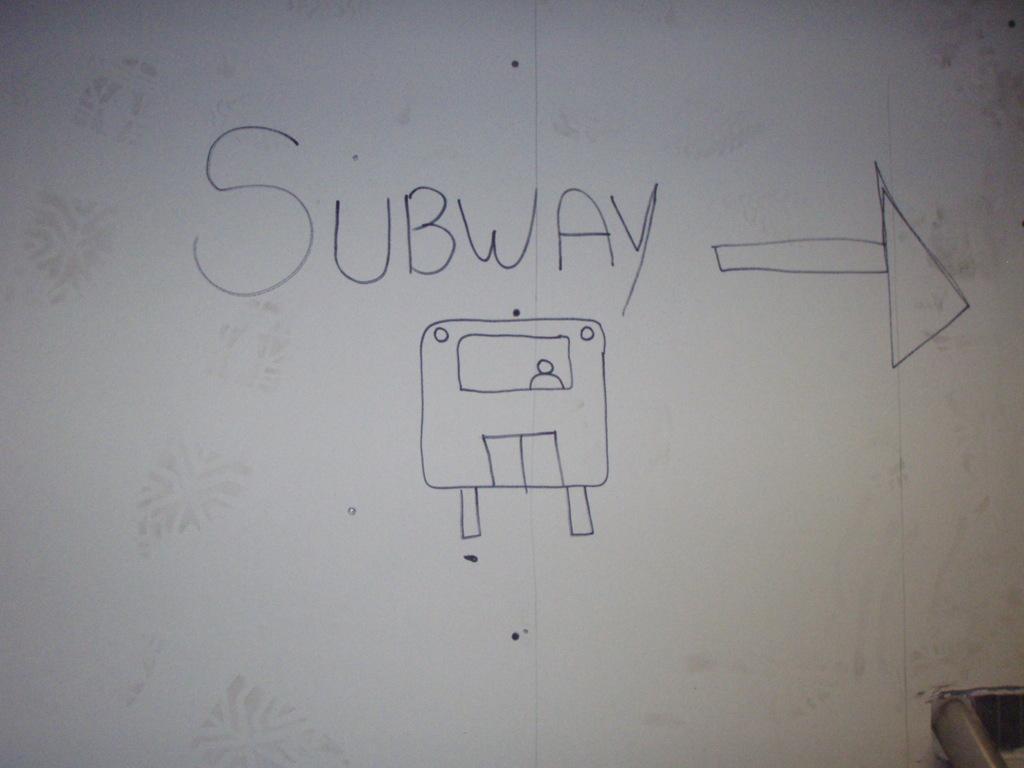Please provide a concise description of this image. In this image I can see the wall, on the wall I can see a text and symbol. 